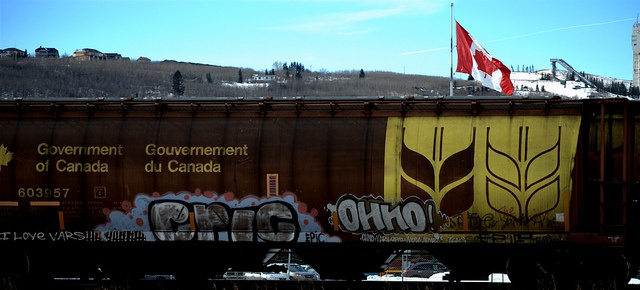Describe the objects in this image and their specific colors. I can see train in lightblue, black, olive, and gray tones, car in lightblue, black, gray, and blue tones, car in lightblue, black, gray, and blue tones, and car in lightblue, gray, white, and darkgray tones in this image. 